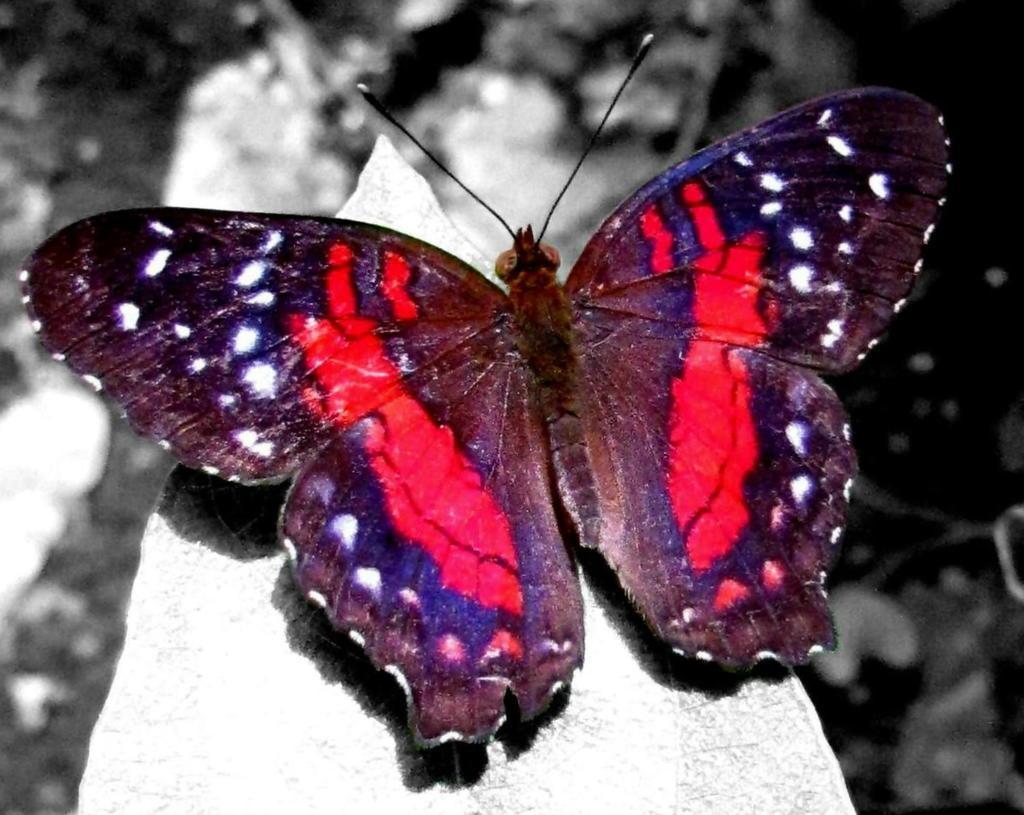In one or two sentences, can you explain what this image depicts? It is a beautiful butterfly which is in red color. 